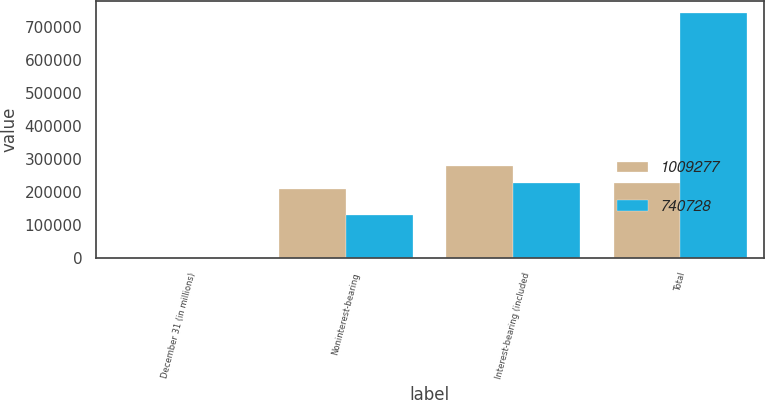Convert chart to OTSL. <chart><loc_0><loc_0><loc_500><loc_500><stacked_bar_chart><ecel><fcel>December 31 (in millions)<fcel>Noninterest-bearing<fcel>Interest-bearing (included<fcel>Total<nl><fcel>1.00928e+06<fcel>2008<fcel>210899<fcel>279604<fcel>228786<nl><fcel>740728<fcel>2007<fcel>129406<fcel>228786<fcel>740728<nl></chart> 